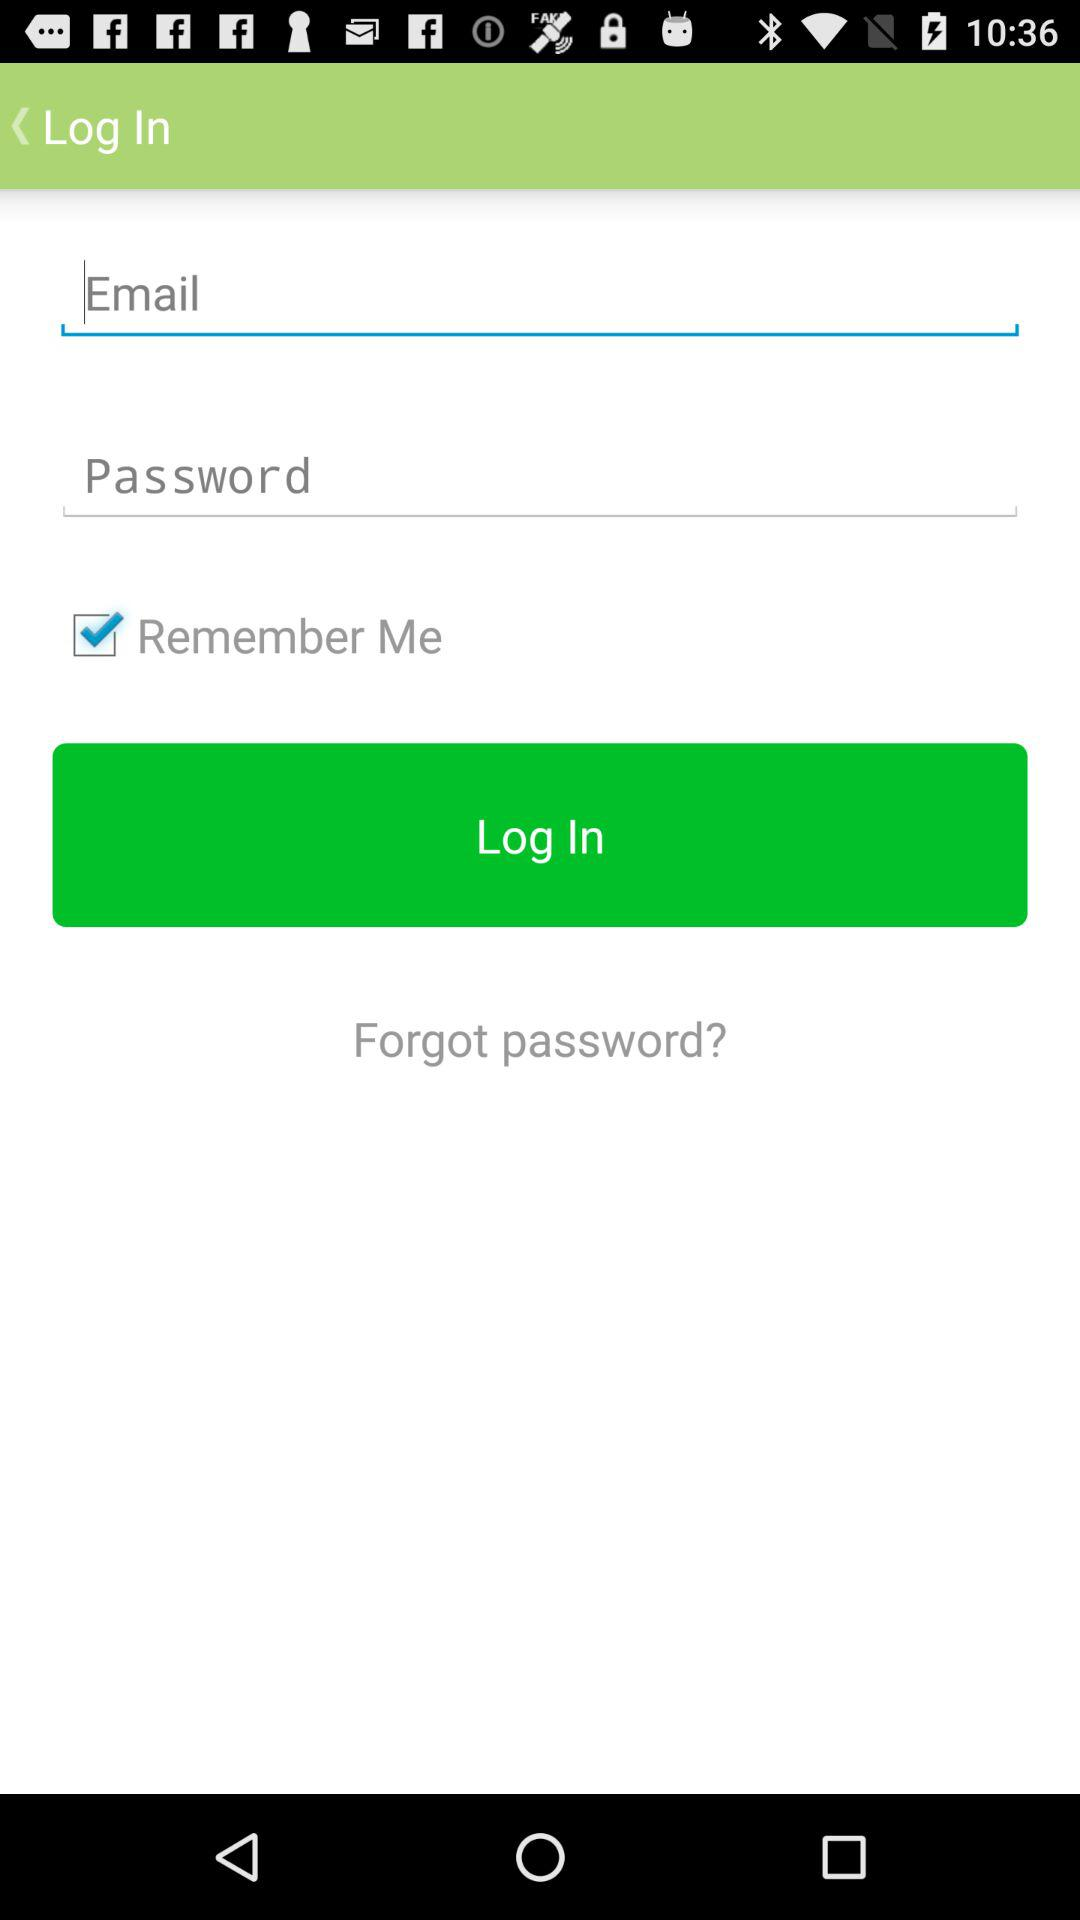What's the status of the "Remember Me" option? The status is "on". 